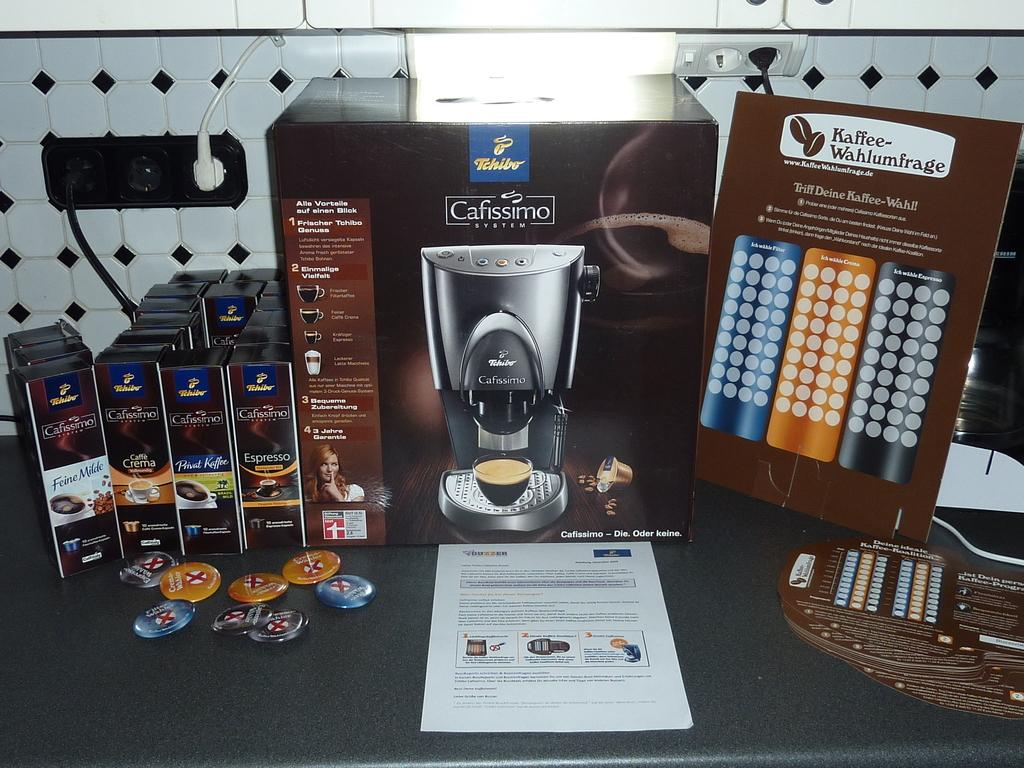<image>
Summarize the visual content of the image. A large box with the words Cafissimo system on it 